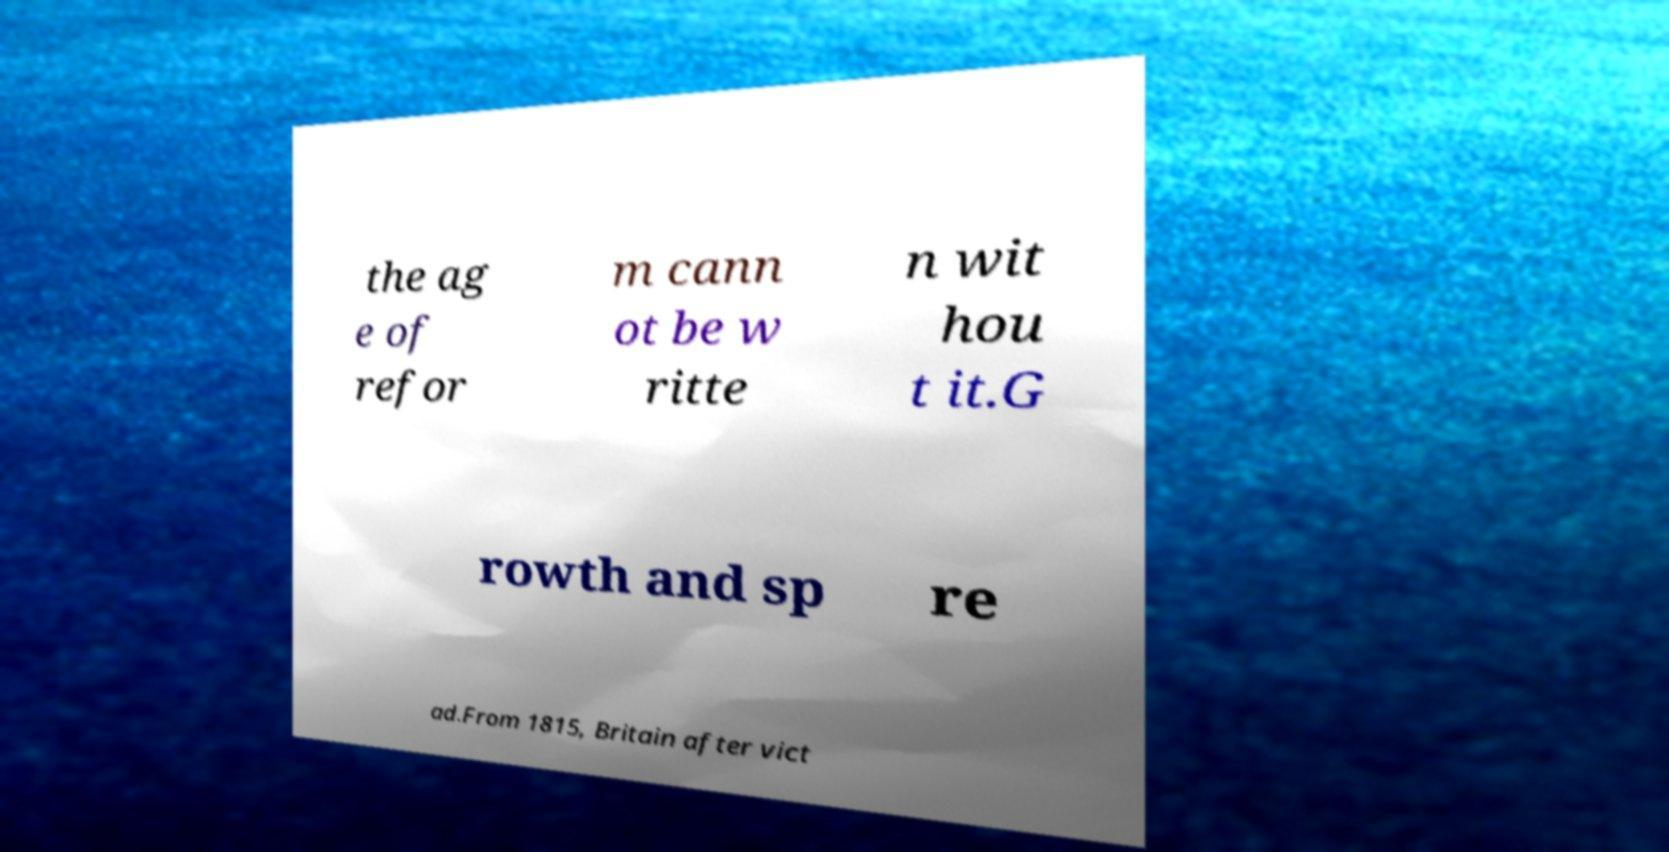Can you read and provide the text displayed in the image?This photo seems to have some interesting text. Can you extract and type it out for me? the ag e of refor m cann ot be w ritte n wit hou t it.G rowth and sp re ad.From 1815, Britain after vict 